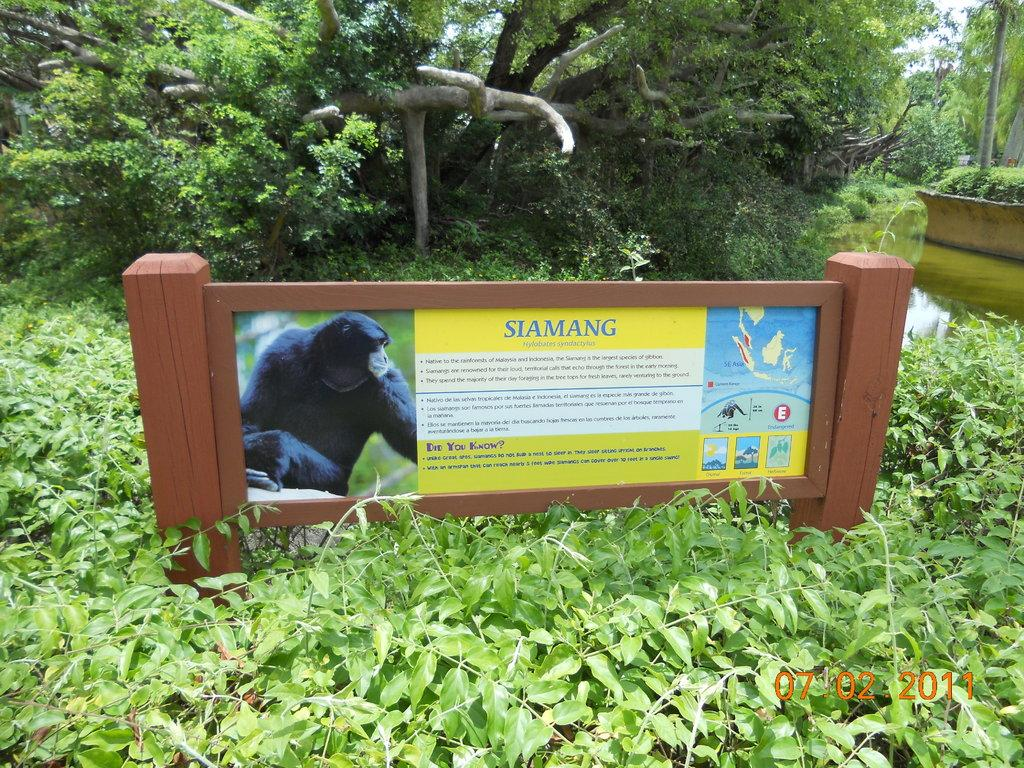What is the main object in the image? There is a board in the image. What is on the board? There are pictures on the board. What can be seen in the background of the image? Water, trees, and the sky are visible in the background of the image. How is the sky described in the image? The sky is visible in the background of the image, and it is described as white in color. What type of snake can be seen slithering on the board in the image? There is no snake present in the image; the board has pictures on it. 